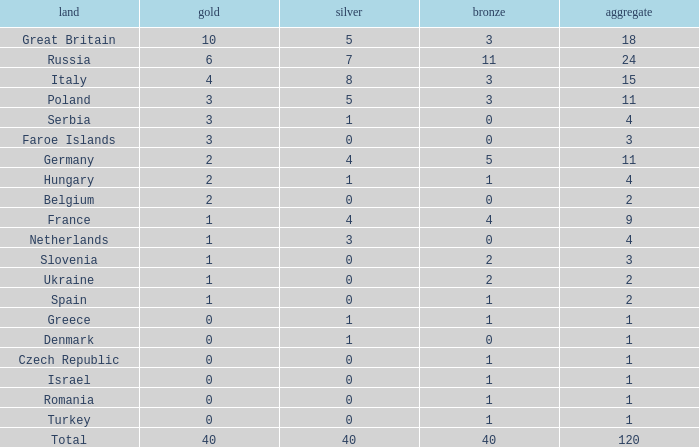What Nation has a Gold entry that is greater than 0, a Total that is greater than 2, a Silver entry that is larger than 1, and 0 Bronze? Netherlands. 